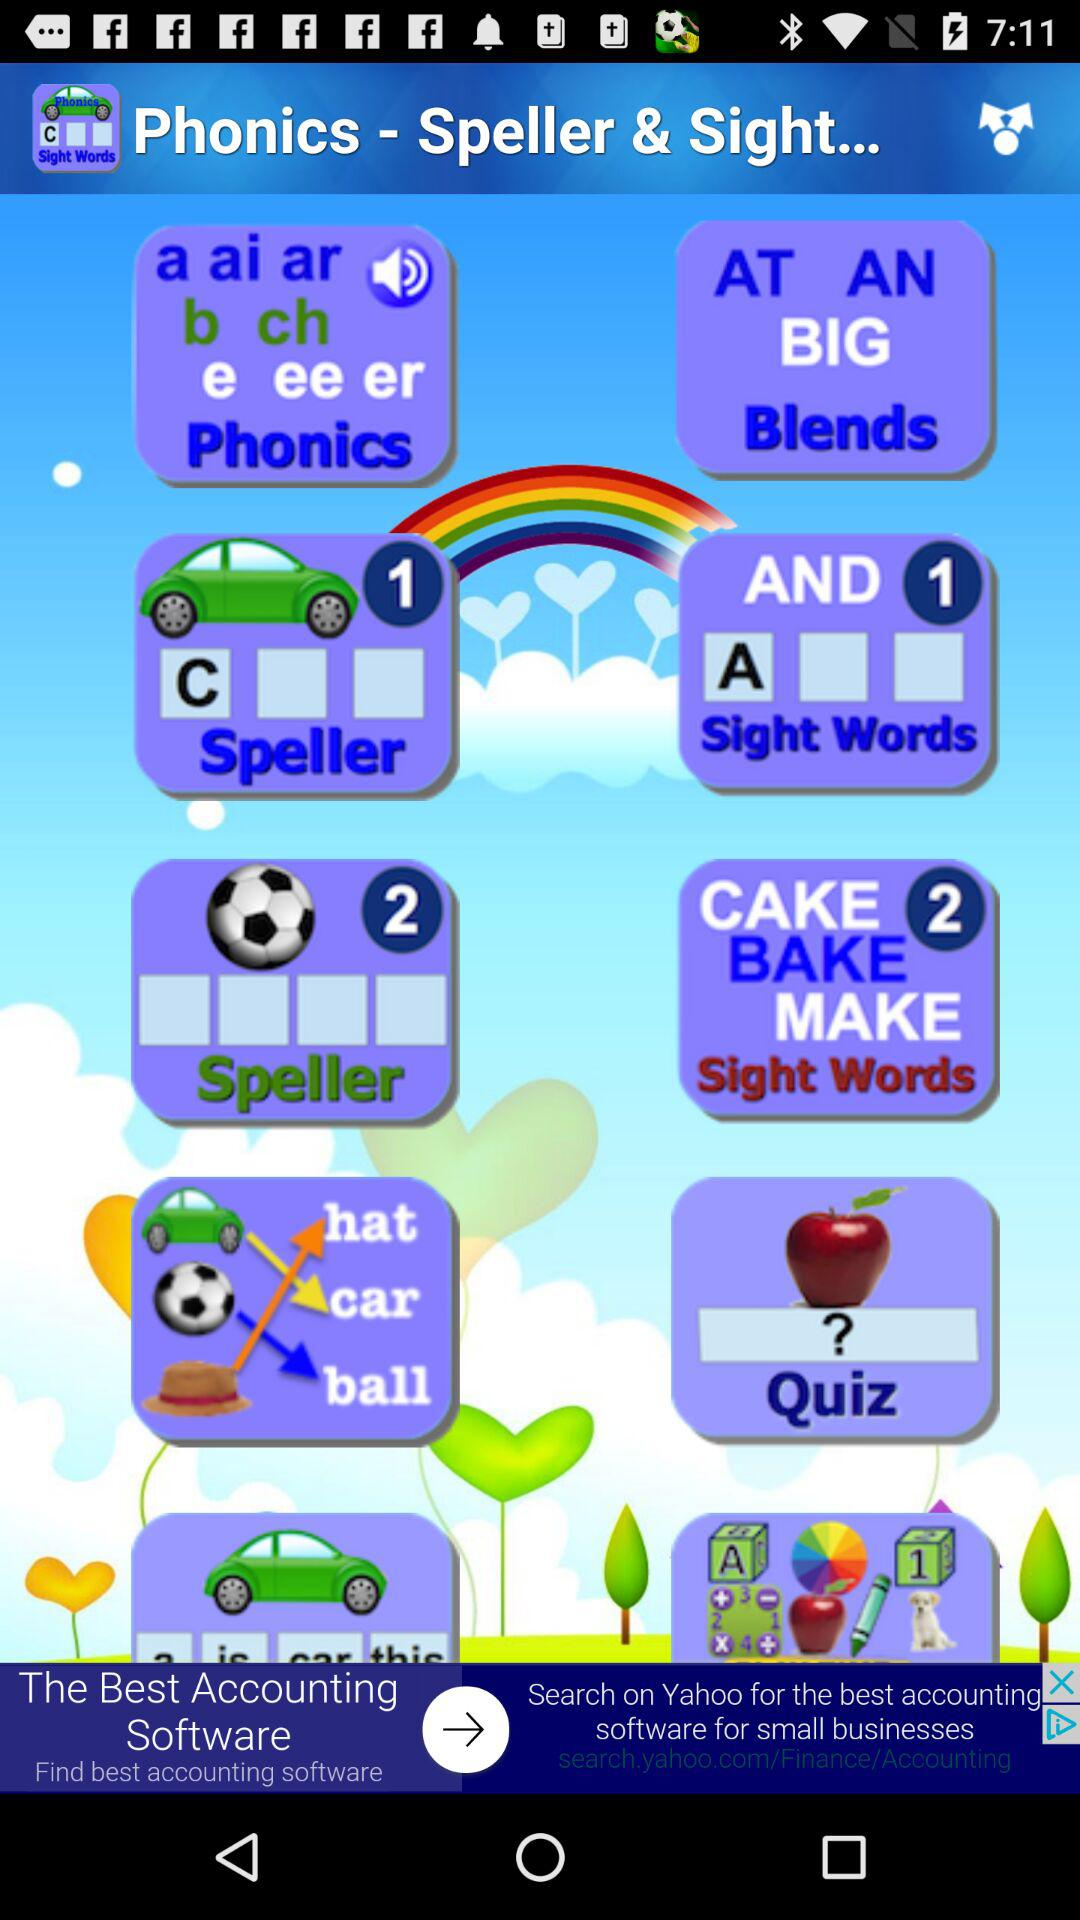What is the name of the application? The name of the application is "Phonics Spelling & Sight Words". 